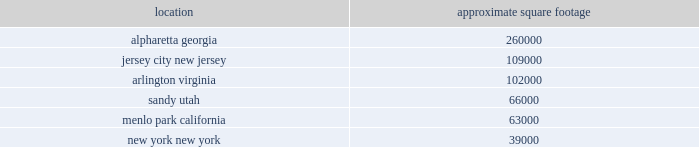
All facilities are leased at december 31 , 2014 , including 165000 square feet of our office in alpharetta , georgia .
We executed a sale-leaseback transaction on this office during 2014 .
See note 9 2014property and equipment , net in item 8 .
Financial statements and supplementary data for more information .
All of our facilities are used by either our trading and investing or balance sheet management segments , in addition to the corporate/other category .
All other leased facilities with space of less than 25000 square feet are not listed by location .
In addition to the significant facilities above , we also lease all 30 e*trade branches , ranging in space from approximately 2500 to 8000 square feet .
We believe our facilities space is adequate to meet our needs in 2015 .
Item 3 .
Legal proceedings on october 27 , 2000 , ajaxo , inc .
( "ajaxo" ) filed a complaint in the superior court for the state of california , county of santa clara .
Ajaxo sought damages and certain non-monetary relief for the company 2019s alleged breach of a non-disclosure agreement with ajaxo pertaining to certain wireless technology that ajaxo offered the company as well as damages and other relief against the company for their alleged misappropriation of ajaxo 2019s trade secrets .
Following a jury trial , a judgment was entered in 2003 in favor of ajaxo against the company for $ 1 million for breach of the ajaxo non-disclosure agreement .
Although the jury found in favor of ajaxo on its claim against the company for misappropriation of trade secrets , the trial court subsequently denied ajaxo 2019s requests for additional damages and relief .
On december 21 , 2005 , the california court of appeal affirmed the above-described award against the company for breach of the nondisclosure agreement but remanded the case to the trial court for the limited purpose of determining what , if any , additional damages ajaxo may be entitled to as a result of the jury 2019s previous finding in favor of ajaxo on its claim against the company for misappropriation of trade secrets .
Although the company paid ajaxo the full amount due on the above-described judgment , the case was remanded back to the trial court , and on may 30 , 2008 , a jury returned a verdict in favor of the company denying all claims raised and demands for damages against the company .
Following the trial court 2019s entry of judgment in favor of the company on september 5 , 2008 , ajaxo filed post- trial motions for vacating this entry of judgment and requesting a new trial .
The trial court denied these motions .
On december 2 , 2008 , ajaxo filed a notice of appeal with the court of appeal of the state of california for the sixth district .
On august 30 , 2010 , the court of appeal affirmed the trial court 2019s verdict in part and reversed the verdict in part , remanding the case .
The company petitioned the supreme court of california for review of the court of appeal decision .
On december 16 , 2010 , the california supreme court denied the company 2019s petition for review and remanded for further proceedings to the trial court .
The testimonial phase of the third trial in this matter concluded on june 12 , 2012 .
By order dated may 28 , 2014 , the court determined to conduct a second phase of this bench trial to allow ajaxo to attempt to prove entitlement to additional royalties .
Hearings in phase two of the trial concluded january 8 , 2015 , and final written closing statements will be submitted march 16 , 2015 .
The company will continue to defend itself vigorously .
On may 16 , 2011 , droplets inc. , the holder of two patents pertaining to user interface servers , filed a complaint in the u.s .
District court for the eastern district of texas against e*trade financial corporation , e*trade securities llc , e*trade bank and multiple other unaffiliated financial services firms .
Plaintiff contends that the defendants engaged in patent infringement under federal law .
Plaintiff seeks unspecified damages and an injunction against future infringements , plus royalties , costs , interest and attorneys 2019 fees .
On september 30 , 2011 , the company and several co-defendants filed a motion to transfer the case to the southern district of new york .
Venue discovery occurred throughout december 2011 .
On january 1 , 2012 , a new judge was assigned to the case .
On march 28 , 2012 , a change of venue was granted and the case was transferred to the united states district court for the southern district of new york .
The company filed its answer and counterclaim on june 13 , 2012 and plaintiff moved to dismiss the counterclaim .
The company filed a motion for summary judgment .
Plaintiffs sought to change venue back to the eastern district of texas on the theory that this case is one of several matters that should be consolidated in a single multi-district litigation .
On december 12 , 2012 , the multidistrict litigation panel denied the transfer of this action to texas .
By opinion dated april 4 , 2013 , the court denied defendants 2019 motion for summary judgment and plaintiff 2019s motion to dismiss the counterclaims .
The court issued its order on claim construction on october 22 , 2013 , and by order dated january 28 , 2014 , the court adopted the defendants' proposed claims construction .
On march 25 , 2014 , the court granted plaintiff leave to amend its complaint to add a newly-issued patent , but stayed all litigation pertaining to that patent until a covered business method review could be heard by the patent and trademark appeals board .
The defendants' petitions for table of contents .
What was the ratio of the square footage in alpharetta georgia to jersey city new jersey as december 2014? 
Rationale: there was 2.39 square footage in alpharetta georgia to each square foot jersey city new jersey as december 2014
Computations: (260000 / 109000)
Answer: 2.38532. 